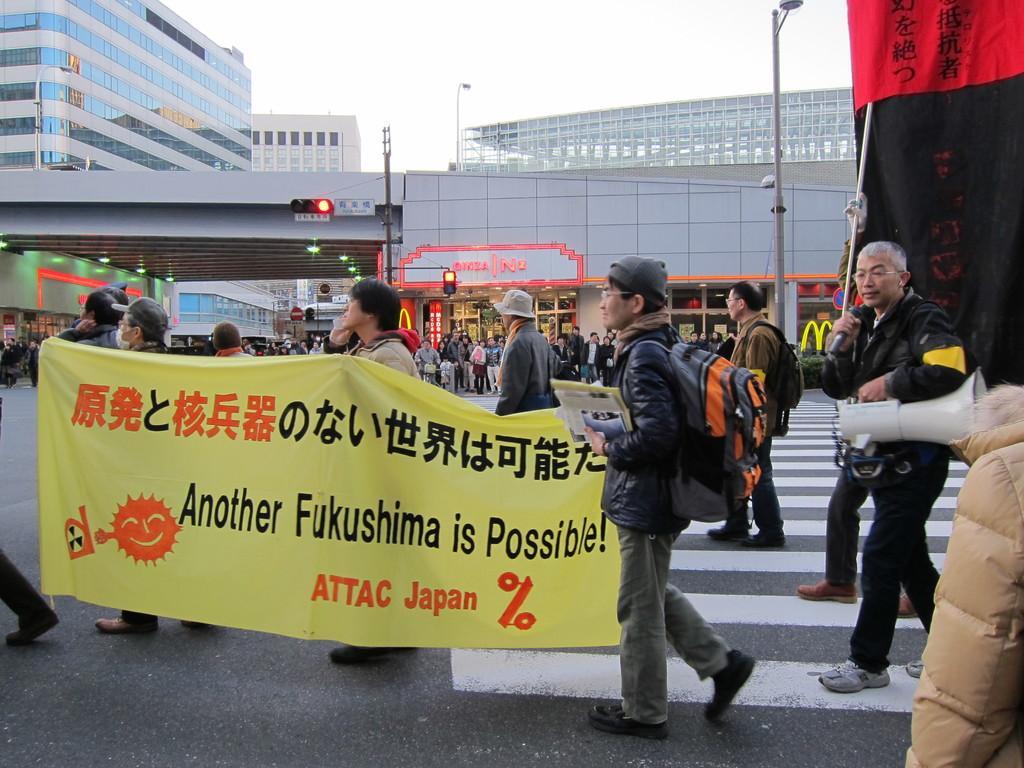Describe this image in one or two sentences. In this image in front there are people walking on the road by holding the banners. Behind them there are a few other people standing on the road. There are street lights, traffic lights. In the background of the image there are buildings and sky. 